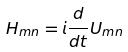<formula> <loc_0><loc_0><loc_500><loc_500>H _ { m n } = i \frac { d } { d t } U _ { m n }</formula> 